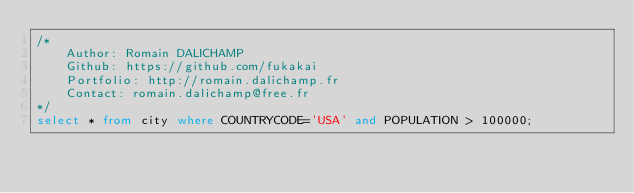Convert code to text. <code><loc_0><loc_0><loc_500><loc_500><_SQL_>/*
	Author: Romain DALICHAMP
	Github: https://github.com/fukakai
	Portfolio: http://romain.dalichamp.fr
	Contact: romain.dalichamp@free.fr
*/
select * from city where COUNTRYCODE='USA' and POPULATION > 100000;</code> 